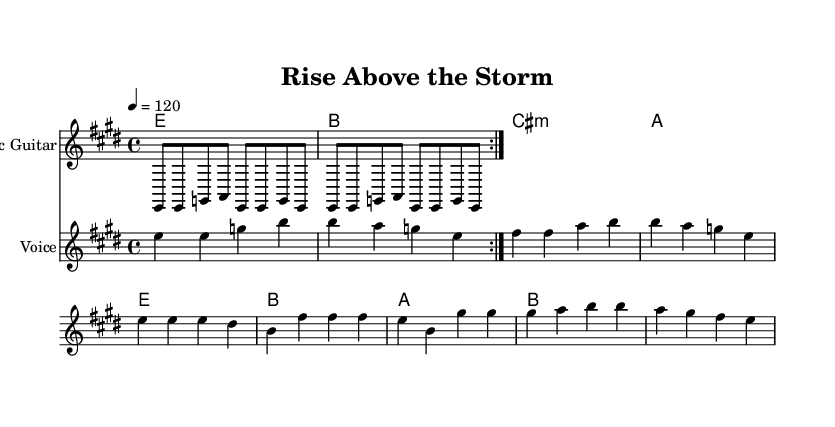What is the key signature of this music? The key signature is E major, which has four sharps (F#, C#, G#, D#). This is determined by looking at the key signature symbol at the beginning of the staff.
Answer: E major What is the time signature of this music? The time signature is 4/4, indicated by the numbers at the beginning of the score. This means there are four beats per measure and the quarter note gets one beat.
Answer: 4/4 What is the tempo marking of this piece? The tempo marking is 120 beats per minute, as shown in the tempo indication in the score, which instructs the player how fast to perform the piece.
Answer: 120 What are the lyrics of the chorus? The lyrics of the chorus are clearly noted below the corresponding melody line in the score, showing the specific words to sing during that section. The lyrics for the chorus are: "I'll rise above the storm".
Answer: I'll rise above the storm How many measures are in the verse? To find the number of measures in the verse, we count the number of vertical lines that separate the music into sections. In this piece, the verse consists of four measures.
Answer: Four Which chord appears first in the verse? The first chord indicated in the verse section follows the chord symbols on the staff. The chord that appears first is E major.
Answer: E What type of musical instrument is primarily featured in this arrangement? The score indicates an electric guitar is specified in the instrument name section of the staff, which shows that this instrument plays the main riffs of the piece.
Answer: Electric guitar 